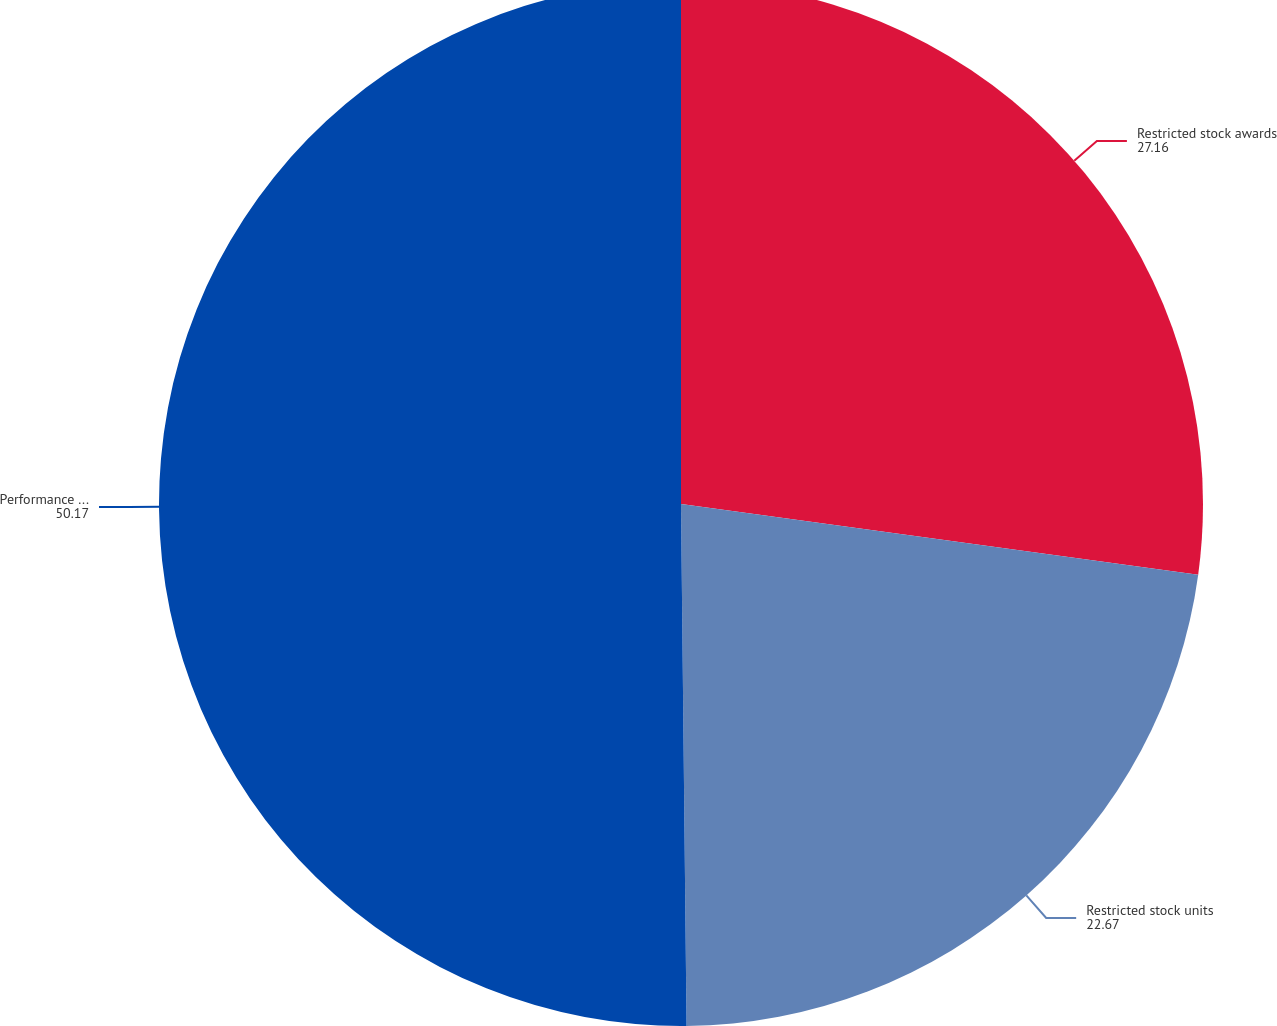<chart> <loc_0><loc_0><loc_500><loc_500><pie_chart><fcel>Restricted stock awards<fcel>Restricted stock units<fcel>Performance share units<nl><fcel>27.16%<fcel>22.67%<fcel>50.17%<nl></chart> 